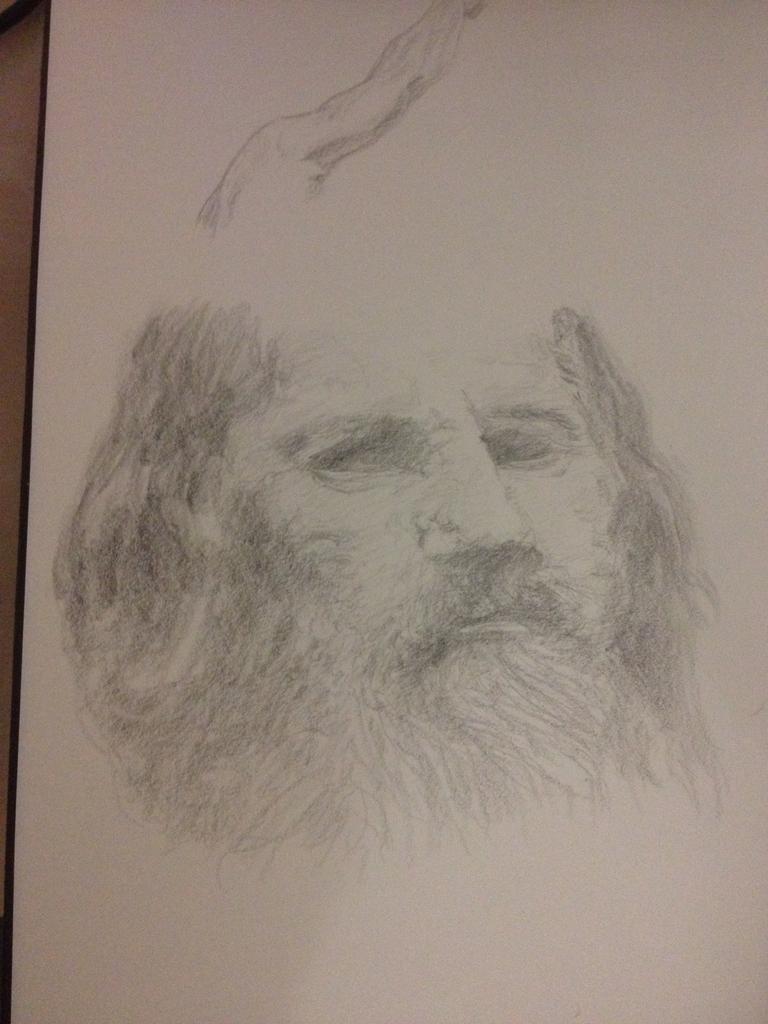How would you summarize this image in a sentence or two? In this image I can see white colour thing and on it I can see sketch of a person's face. 